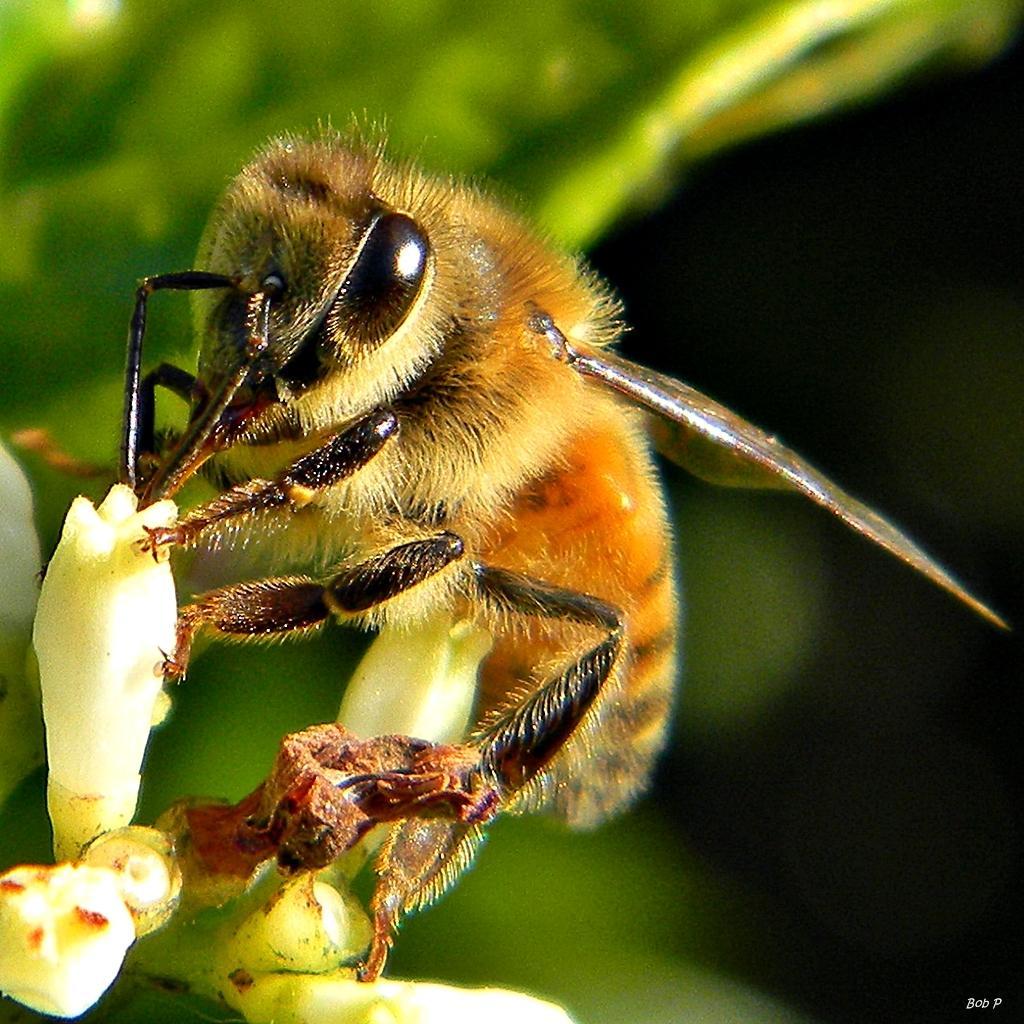Please provide a concise description of this image. In this picture we can see an insect on a bud. Background is blurry. 